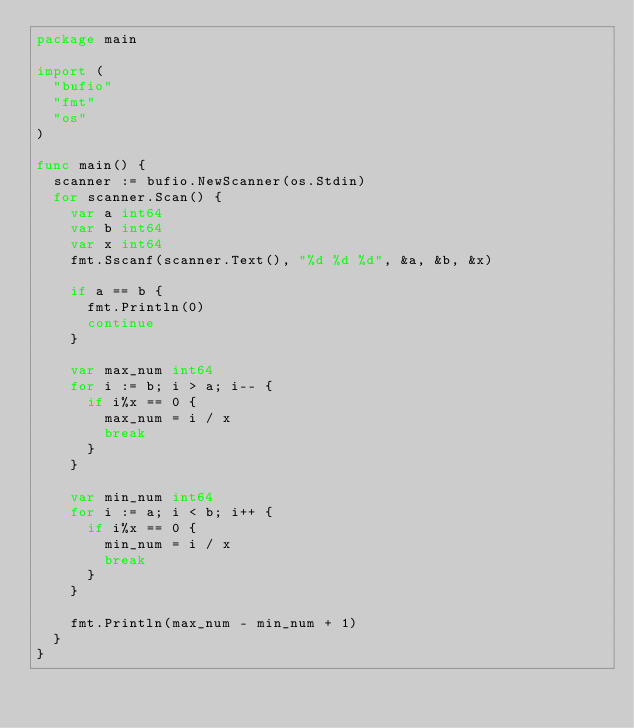Convert code to text. <code><loc_0><loc_0><loc_500><loc_500><_Go_>package main

import (
	"bufio"
	"fmt"
	"os"
)

func main() {
	scanner := bufio.NewScanner(os.Stdin)
	for scanner.Scan() {
		var a int64
		var b int64
		var x int64
		fmt.Sscanf(scanner.Text(), "%d %d %d", &a, &b, &x)

		if a == b {
			fmt.Println(0)
			continue
		}

		var max_num int64
		for i := b; i > a; i-- {
			if i%x == 0 {
				max_num = i / x
				break
			}
		}

		var min_num int64
		for i := a; i < b; i++ {
			if i%x == 0 {
				min_num = i / x
				break
			}
		}

		fmt.Println(max_num - min_num + 1)
	}
}
</code> 